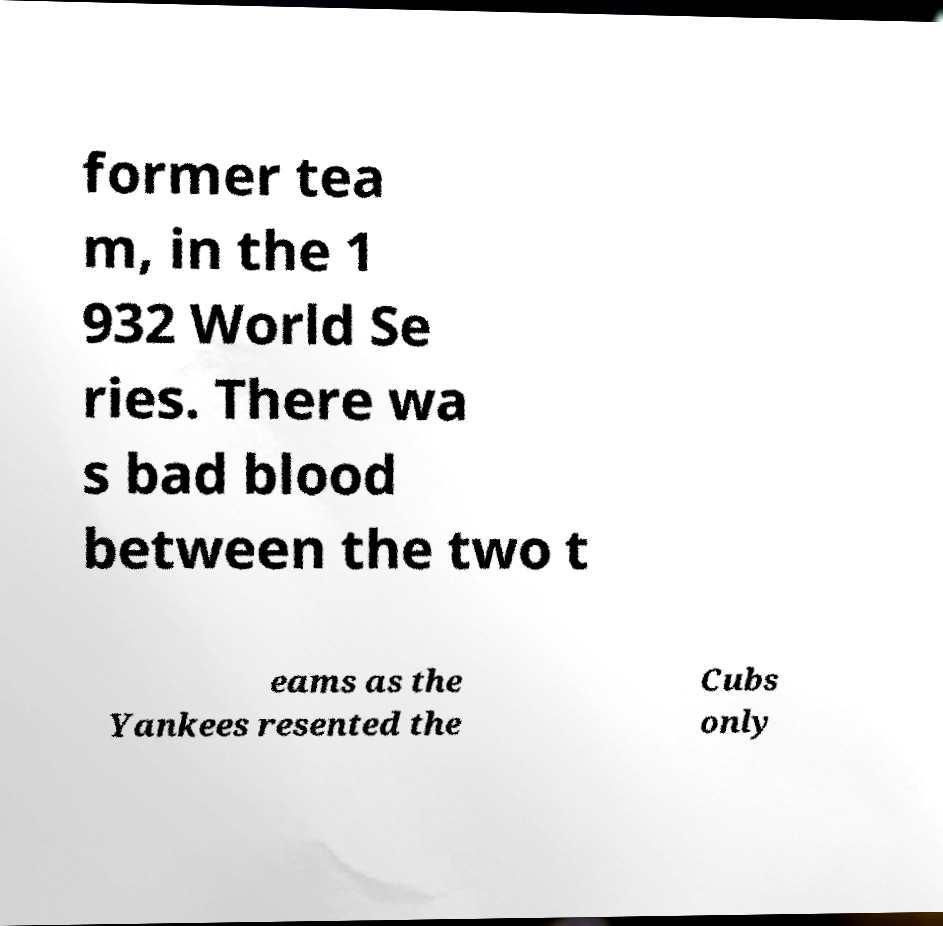Please read and relay the text visible in this image. What does it say? former tea m, in the 1 932 World Se ries. There wa s bad blood between the two t eams as the Yankees resented the Cubs only 